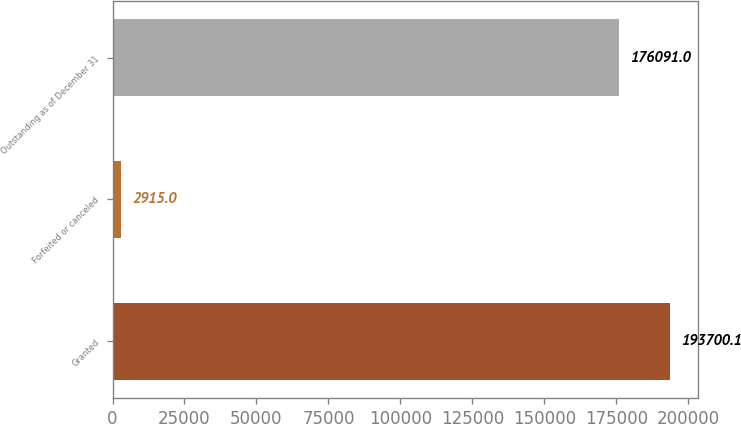<chart> <loc_0><loc_0><loc_500><loc_500><bar_chart><fcel>Granted<fcel>Forfeited or canceled<fcel>Outstanding as of December 31<nl><fcel>193700<fcel>2915<fcel>176091<nl></chart> 